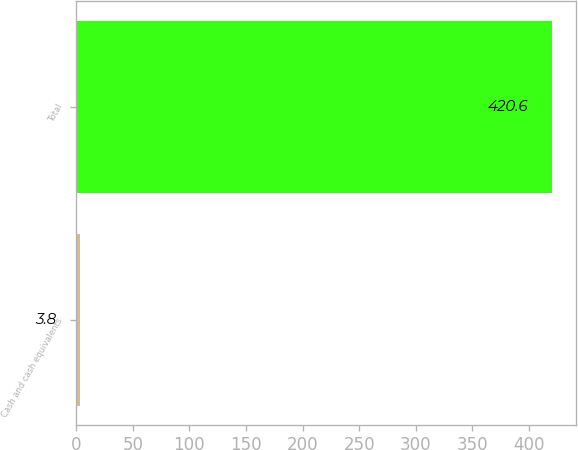<chart> <loc_0><loc_0><loc_500><loc_500><bar_chart><fcel>Cash and cash equivalents<fcel>Total<nl><fcel>3.8<fcel>420.6<nl></chart> 